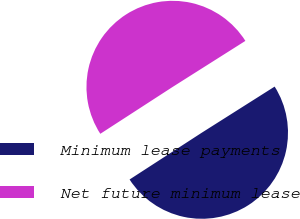<chart> <loc_0><loc_0><loc_500><loc_500><pie_chart><fcel>Minimum lease payments<fcel>Net future minimum lease<nl><fcel>49.83%<fcel>50.17%<nl></chart> 